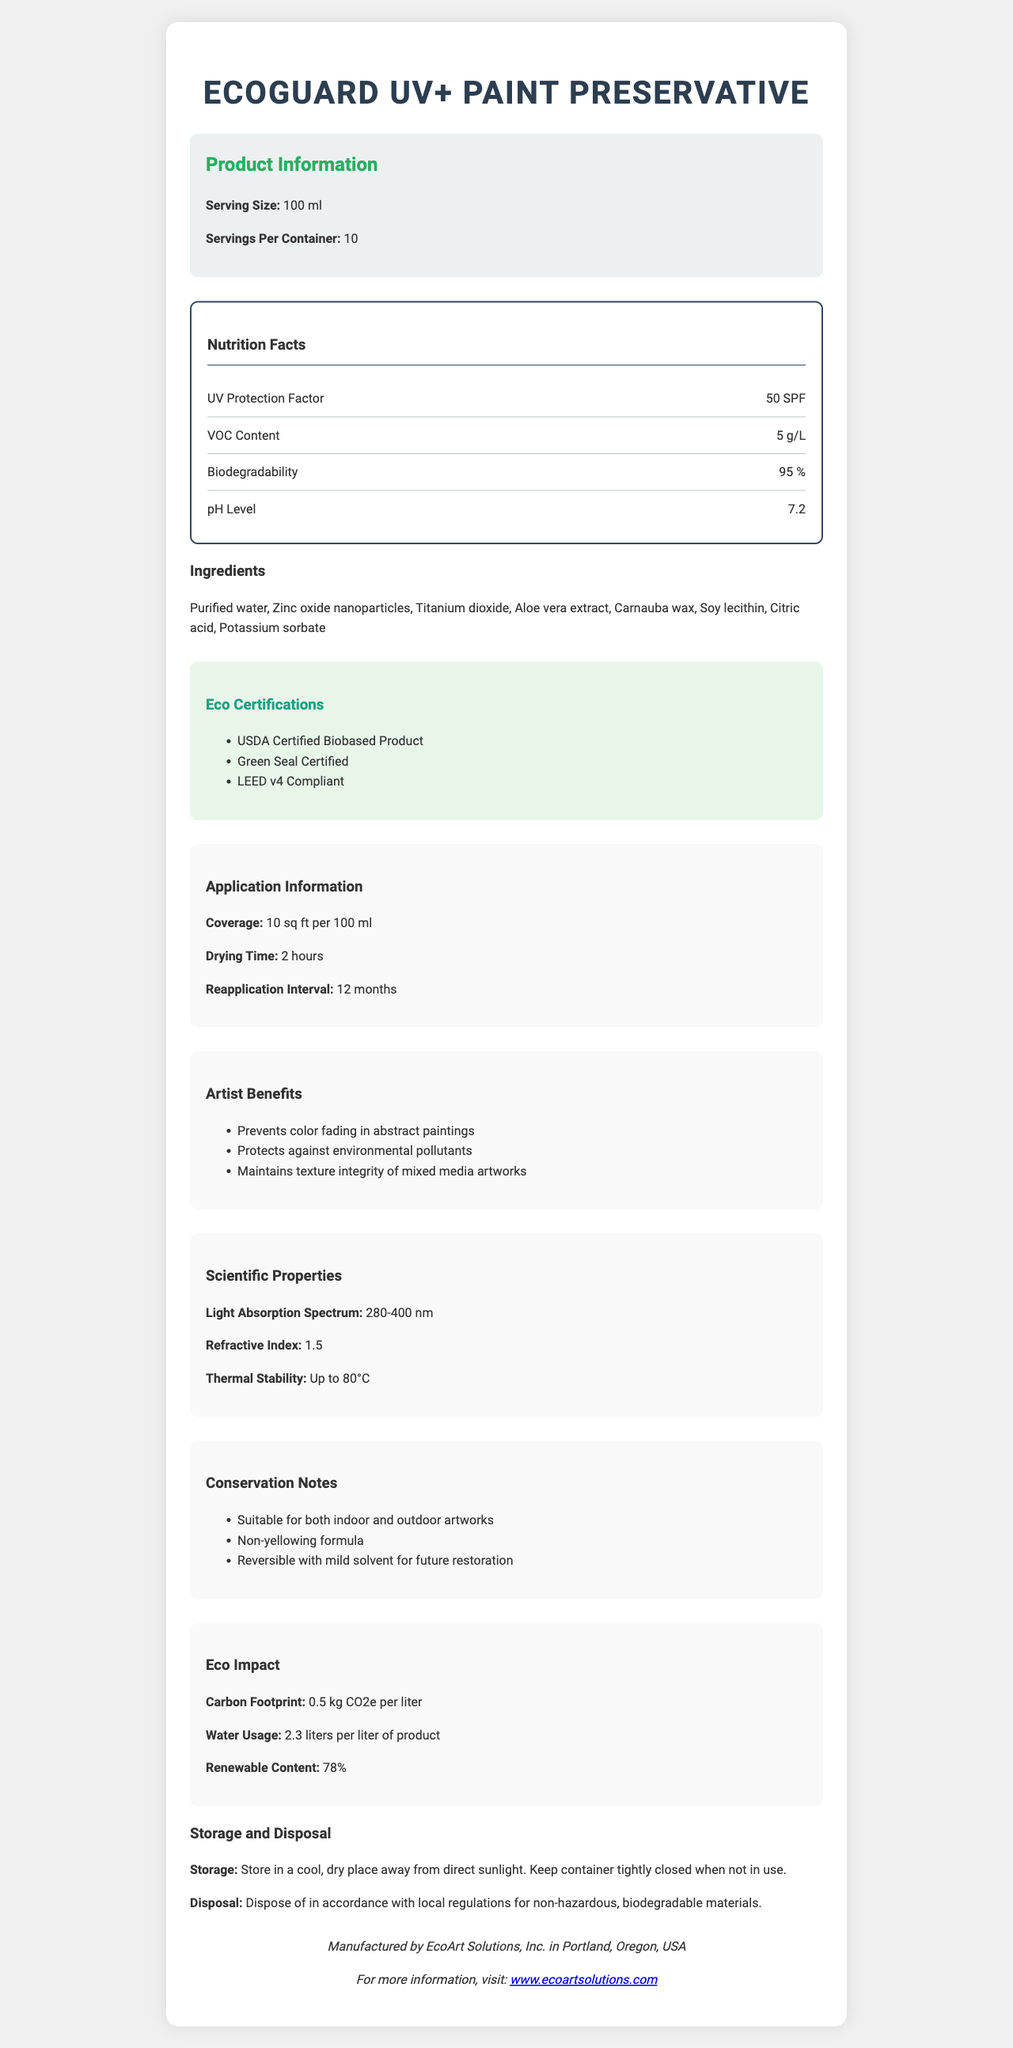what is the serving size for EcoGuard UV+ Paint Preservative? The document mentions that the serving size for EcoGuard UV+ Paint Preservative is 100 ml.
Answer: 100 ml How many servings per container are there for this product? The document specifies that there are 10 servings per container for this product.
Answer: 10 What is the UV Protection Factor (SPF) of this paint preservative? Under the "nutrition facts" section, the UV Protection Factor is listed as 50 SPF.
Answer: 50 SPF What is the thermal stability of the EcoGuard UV+? The "scientific properties" section mentions that the thermal stability of EcoGuard UV+ is up to 80°C.
Answer: Up to 80°C Is the formula reversible for future restoration? The "conservation notes" section states that EcoGuard UV+ Paint Preservative has a reversible formula with mild solvents for future restoration.
Answer: Yes What ingredients are included in this paint preservative? The document lists these ingredients under the ingredients section.
Answer: Purified water, Zinc oxide nanoparticles, Titanium dioxide, Aloe vera extract, Carnauba wax, Soy lecithin, Citric acid, Potassium sorbate Which eco certifications does EcoGuard UV+ have? The "Eco Certifications" section lists these certifications.
Answer: USDA Certified Biobased Product, Green Seal Certified, LEED v4 Compliant What are the artist benefits of using EcoGuard UV+? The "artist benefits" section lists these advantages.
Answer: Prevents color fading in abstract paintings, Protects against environmental pollutants, Maintains texture integrity of mixed media artworks How much coverage can be achieved with 100 ml of this product? The "application information" notes that 100 ml of the product covers 10 sq ft.
Answer: 10 sq ft What is the pH Level of the product? The "nutrition facts" section lists the pH Level as 7.2.
Answer: 7.2 How should EcoGuard UV+ Paint Preservative be stored? The "storage instructions" paragraph details the proper storage method.
Answer: Store in a cool, dry place away from direct sunlight. Keep container tightly closed when not in use. What is the carbon footprint of one liter of this product? A. 0.5 kg CO2e B. 1 kg CO2e C. 1.5 kg CO2e D. 2 kg CO2e The "eco impact" section states that the carbon footprint per liter is 0.5 kg CO2e.
Answer: A What is the light absorption spectrum range of EcoGuard UV+? A. 200-400 nm B. 280-400 nm C. 320-420 nm D. 350-450 nm The "scientific properties" section lists the light absorption spectrum as 280-400 nm.
Answer: B Is this product suitable for both indoor and outdoor artworks? The "conservation notes" section mentions that the product is suitable for both indoor and outdoor artworks.
Answer: Yes Summarize the main aspects of EcoGuard UV+ Paint Preservative. This summary captures various key elements from the document, covering ingredients, benefits, application instructions, and certifications.
Answer: EcoGuard UV+ is an eco-friendly paint preservative with UV protection properties. It has a serving size of 100 ml and offers 10 servings per container. Key ingredients include purified water, zinc oxide nanoparticles, and aloe vera extract. It offers substantial UV protection, low VOC content, and high biodegradability. Artist benefits include preventing color fading, protecting against pollutants, and maintaining texture integrity. The product is certified as eco-friendly and suitable for both indoor and outdoor artworks, with easy reversibility for future restoration. It should be stored in a cool, dry place and disposed of as per local biodegradable guidelines. What is the refractive index of EcoGuard UV+? The "scientific properties" section of the document lists a refractive index of 1.5.
Answer: 1.5 Who manufactures EcoGuard UV+ Paint Preservative? A. EcoArt Enterprises B. Green Solutions Inc. C. BioPaints Co. D. EcoArt Solutions, Inc. The "manufacturer info" section indicates that the product is manufactured by EcoArt Solutions, Inc.
Answer: D What is the percentage of renewable content in this product? The "eco impact" section notes that the renewable content is 78%.
Answer: 78% What is the chemical formula for potassium sorbate? The document provides the list of ingredients but does not specify the chemical formulas for them.
Answer: Cannot be determined 